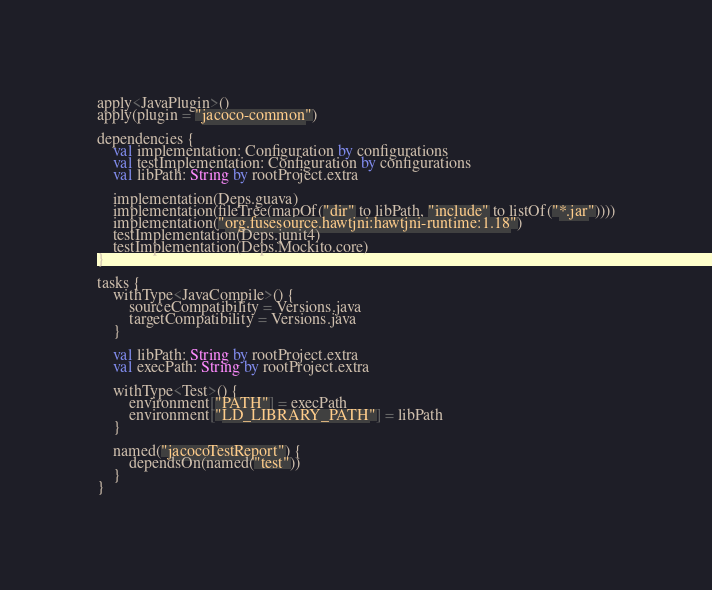Convert code to text. <code><loc_0><loc_0><loc_500><loc_500><_Kotlin_>apply<JavaPlugin>()
apply(plugin = "jacoco-common")

dependencies {
    val implementation: Configuration by configurations
    val testImplementation: Configuration by configurations
    val libPath: String by rootProject.extra

    implementation(Deps.guava)
    implementation(fileTree(mapOf("dir" to libPath, "include" to listOf("*.jar"))))
    implementation("org.fusesource.hawtjni:hawtjni-runtime:1.18")
    testImplementation(Deps.junit4)
    testImplementation(Deps.Mockito.core)
}

tasks {
    withType<JavaCompile>() {
        sourceCompatibility = Versions.java
        targetCompatibility = Versions.java
    }

    val libPath: String by rootProject.extra
    val execPath: String by rootProject.extra

    withType<Test>() {
        environment["PATH"] = execPath
        environment["LD_LIBRARY_PATH"] = libPath
    }

    named("jacocoTestReport") {
        dependsOn(named("test"))
    }
}
</code> 